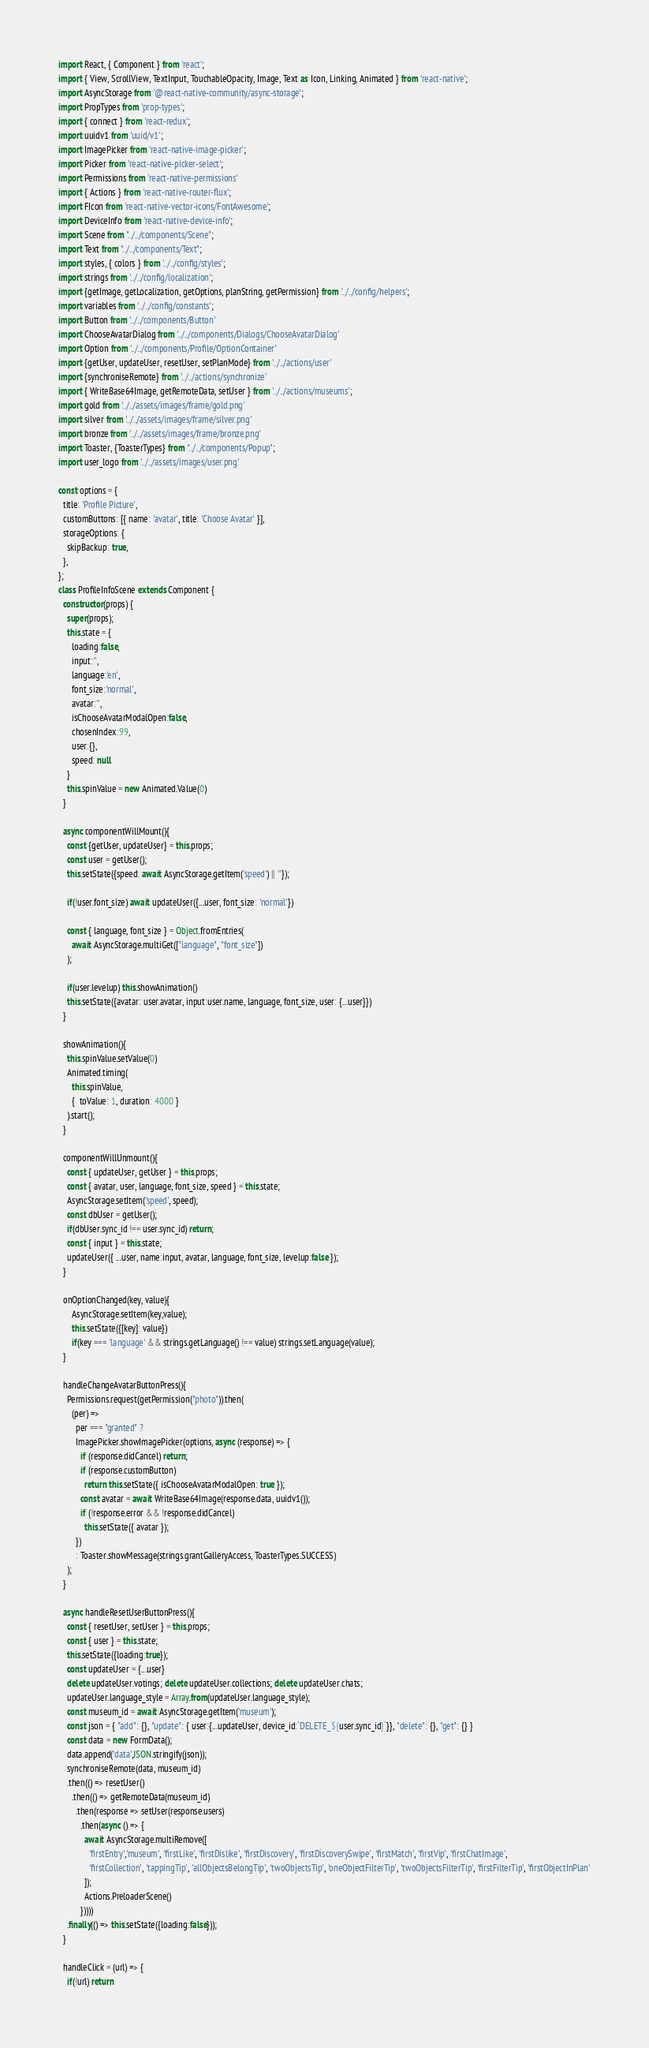Convert code to text. <code><loc_0><loc_0><loc_500><loc_500><_JavaScript_>import React, { Component } from 'react';
import { View, ScrollView, TextInput, TouchableOpacity, Image, Text as Icon, Linking, Animated } from 'react-native';
import AsyncStorage from '@react-native-community/async-storage';
import PropTypes from 'prop-types';
import { connect } from 'react-redux';
import uuidv1 from 'uuid/v1';
import ImagePicker from 'react-native-image-picker';
import Picker from 'react-native-picker-select';
import Permissions from 'react-native-permissions'
import { Actions } from 'react-native-router-flux';
import FIcon from 'react-native-vector-icons/FontAwesome';
import DeviceInfo from 'react-native-device-info';
import Scene from "../../components/Scene";
import Text from "../../components/Text";
import styles, { colors } from '../../config/styles';
import strings from '../../config/localization';
import {getImage, getLocalization, getOptions, planString, getPermission} from '../../config/helpers';
import variables from '../../config/constants';
import Button from '../../components/Button'
import ChooseAvatarDialog from '../../components/Dialogs/ChooseAvatarDialog'
import Option from '../../components/Profile/OptionContainer'
import {getUser, updateUser, resetUser, setPlanMode} from '../../actions/user'
import {synchroniseRemote} from '../../actions/synchronize'
import { WriteBase64Image, getRemoteData, setUser } from '../../actions/museums';
import gold from '../../assets/images/frame/gold.png'
import silver from '../../assets/images/frame/silver.png'
import bronze from '../../assets/images/frame/bronze.png'
import Toaster, {ToasterTypes} from "../../components/Popup";
import user_logo from '../../assets/images/user.png'

const options = {
  title: 'Profile Picture',
  customButtons: [{ name: 'avatar', title: 'Choose Avatar' }],
  storageOptions: {
    skipBackup: true,
  },
};
class ProfileInfoScene extends Component {
  constructor(props) {
    super(props);
    this.state = {
      loading:false,
      input:'',
      language:'en',
      font_size:'normal',
      avatar:'',
      isChooseAvatarModalOpen:false,
      chosenIndex:99,
      user:{},
      speed: null
    }
    this.spinValue = new Animated.Value(0)
  }

  async componentWillMount(){
    const {getUser, updateUser} = this.props;
    const user = getUser();
    this.setState({speed: await AsyncStorage.getItem('speed') || ''});

    if(!user.font_size) await updateUser({...user, font_size: 'normal'})

    const { language, font_size } = Object.fromEntries(
      await AsyncStorage.multiGet(["language", "font_size"])
    );

    if(user.levelup) this.showAnimation()
    this.setState({avatar: user.avatar, input:user.name, language, font_size, user: {...user}})
  }

  showAnimation(){
    this.spinValue.setValue(0)
    Animated.timing(
      this.spinValue,
      {  toValue: 1, duration: 4000 }
    ).start();
  }

  componentWillUnmount(){
    const { updateUser, getUser } = this.props;
    const { avatar, user, language, font_size, speed } = this.state;
    AsyncStorage.setItem('speed', speed);
    const dbUser = getUser();
    if(dbUser.sync_id !== user.sync_id) return;
    const { input } = this.state;
    updateUser({ ...user, name:input, avatar, language, font_size, levelup:false });
  }

  onOptionChanged(key, value){
      AsyncStorage.setItem(key,value);
      this.setState({[key]: value})
      if(key === 'language' && strings.getLanguage() !== value) strings.setLanguage(value); 
  }

  handleChangeAvatarButtonPress(){
    Permissions.request(getPermission("photo")).then(
      (per) =>
        per === "granted" ?
        ImagePicker.showImagePicker(options, async (response) => {
          if (response.didCancel) return;
          if (response.customButton)
            return this.setState({ isChooseAvatarModalOpen: true });
          const avatar = await WriteBase64Image(response.data, uuidv1());
          if (!response.error && !response.didCancel)
            this.setState({ avatar });
        })
        : Toaster.showMessage(strings.grantGalleryAccess, ToasterTypes.SUCCESS)
    );
  }

  async handleResetUserButtonPress(){
    const { resetUser, setUser } = this.props;
    const { user } = this.state;
    this.setState({loading:true});
    const updateUser = {...user}
    delete updateUser.votings; delete updateUser.collections; delete updateUser.chats;    
    updateUser.language_style = Array.from(updateUser.language_style);
    const museum_id = await AsyncStorage.getItem('museum');
    const json = { "add": {}, "update": { user:{...updateUser, device_id:`DELETE_${user.sync_id}`}}, "delete": {}, "get": {} }
    const data = new FormData();
    data.append('data',JSON.stringify(json));
    synchroniseRemote(data, museum_id)
    .then(() => resetUser()
      .then(() => getRemoteData(museum_id)
        .then(response => setUser(response.users)
          .then(async () => {
            await AsyncStorage.multiRemove([
              'firstEntry','museum', 'firstLike', 'firstDislike', 'firstDiscovery', 'firstDiscoverySwipe', 'firstMatch', 'firstVip', 'firstChatImage',
              'firstCollection', 'tappingTip', 'allObjectsBelongTip', 'twoObjectsTip', 'oneObjectFilterTip', 'twoObjectsFilterTip', 'firstFilterTip', 'firstObjectInPlan'
            ]);
            Actions.PreloaderScene()
          }))))
    .finally(() => this.setState({loading:false}));
  }

  handleClick = (url) => {
    if(!url) return</code> 